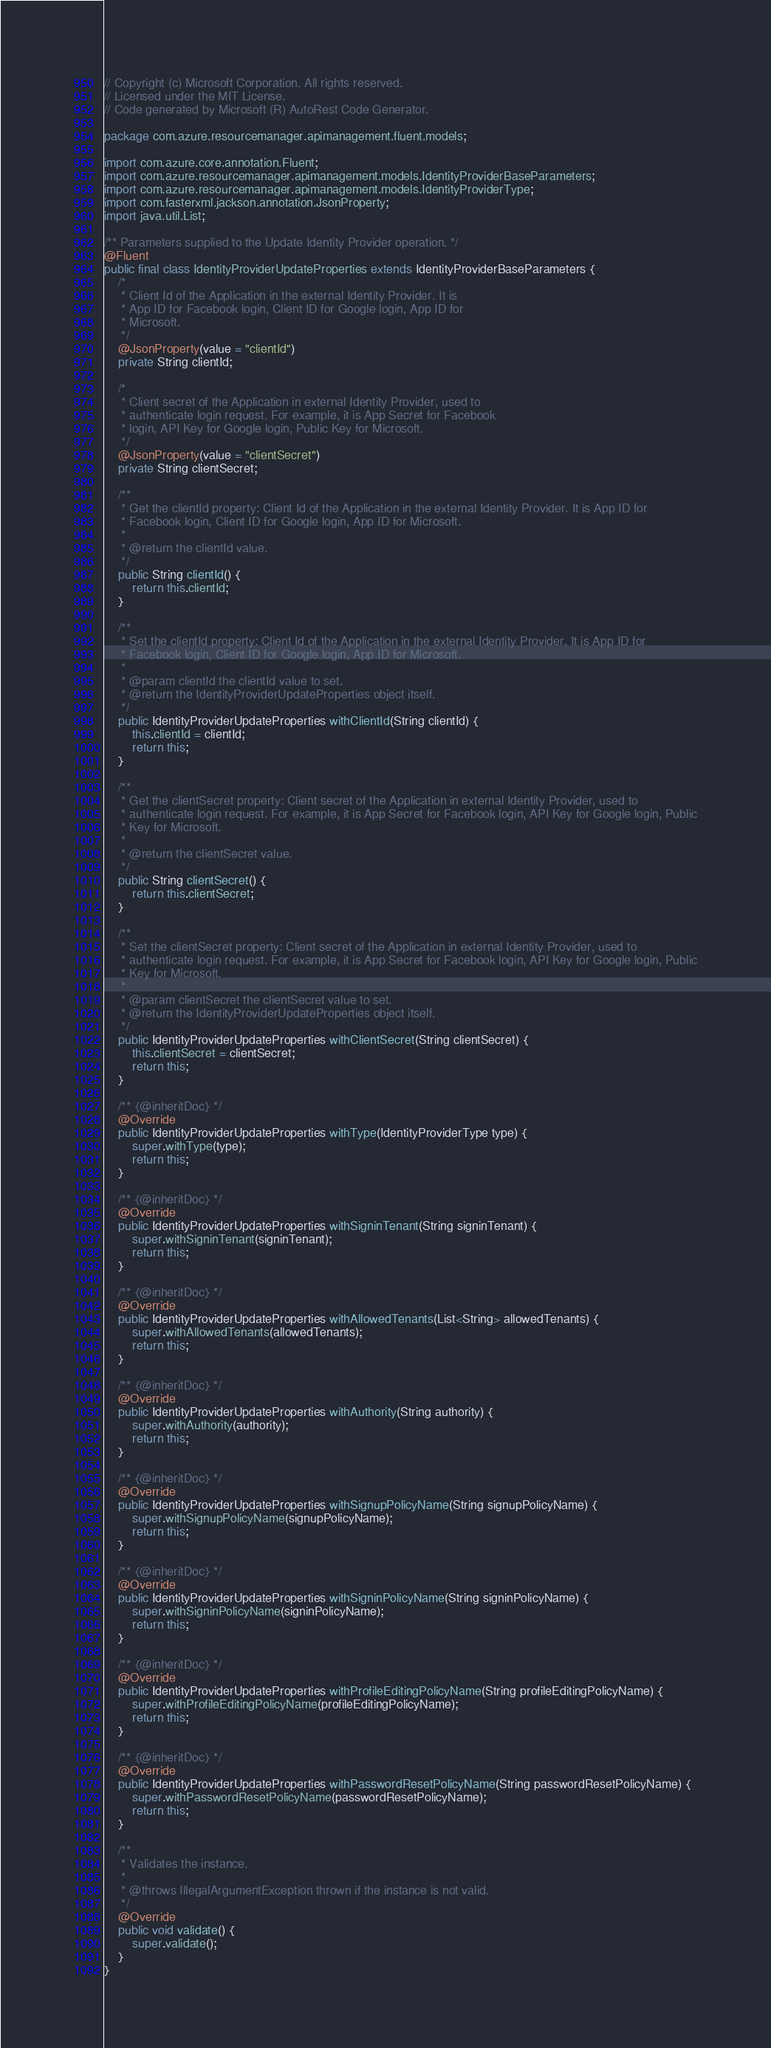Convert code to text. <code><loc_0><loc_0><loc_500><loc_500><_Java_>// Copyright (c) Microsoft Corporation. All rights reserved.
// Licensed under the MIT License.
// Code generated by Microsoft (R) AutoRest Code Generator.

package com.azure.resourcemanager.apimanagement.fluent.models;

import com.azure.core.annotation.Fluent;
import com.azure.resourcemanager.apimanagement.models.IdentityProviderBaseParameters;
import com.azure.resourcemanager.apimanagement.models.IdentityProviderType;
import com.fasterxml.jackson.annotation.JsonProperty;
import java.util.List;

/** Parameters supplied to the Update Identity Provider operation. */
@Fluent
public final class IdentityProviderUpdateProperties extends IdentityProviderBaseParameters {
    /*
     * Client Id of the Application in the external Identity Provider. It is
     * App ID for Facebook login, Client ID for Google login, App ID for
     * Microsoft.
     */
    @JsonProperty(value = "clientId")
    private String clientId;

    /*
     * Client secret of the Application in external Identity Provider, used to
     * authenticate login request. For example, it is App Secret for Facebook
     * login, API Key for Google login, Public Key for Microsoft.
     */
    @JsonProperty(value = "clientSecret")
    private String clientSecret;

    /**
     * Get the clientId property: Client Id of the Application in the external Identity Provider. It is App ID for
     * Facebook login, Client ID for Google login, App ID for Microsoft.
     *
     * @return the clientId value.
     */
    public String clientId() {
        return this.clientId;
    }

    /**
     * Set the clientId property: Client Id of the Application in the external Identity Provider. It is App ID for
     * Facebook login, Client ID for Google login, App ID for Microsoft.
     *
     * @param clientId the clientId value to set.
     * @return the IdentityProviderUpdateProperties object itself.
     */
    public IdentityProviderUpdateProperties withClientId(String clientId) {
        this.clientId = clientId;
        return this;
    }

    /**
     * Get the clientSecret property: Client secret of the Application in external Identity Provider, used to
     * authenticate login request. For example, it is App Secret for Facebook login, API Key for Google login, Public
     * Key for Microsoft.
     *
     * @return the clientSecret value.
     */
    public String clientSecret() {
        return this.clientSecret;
    }

    /**
     * Set the clientSecret property: Client secret of the Application in external Identity Provider, used to
     * authenticate login request. For example, it is App Secret for Facebook login, API Key for Google login, Public
     * Key for Microsoft.
     *
     * @param clientSecret the clientSecret value to set.
     * @return the IdentityProviderUpdateProperties object itself.
     */
    public IdentityProviderUpdateProperties withClientSecret(String clientSecret) {
        this.clientSecret = clientSecret;
        return this;
    }

    /** {@inheritDoc} */
    @Override
    public IdentityProviderUpdateProperties withType(IdentityProviderType type) {
        super.withType(type);
        return this;
    }

    /** {@inheritDoc} */
    @Override
    public IdentityProviderUpdateProperties withSigninTenant(String signinTenant) {
        super.withSigninTenant(signinTenant);
        return this;
    }

    /** {@inheritDoc} */
    @Override
    public IdentityProviderUpdateProperties withAllowedTenants(List<String> allowedTenants) {
        super.withAllowedTenants(allowedTenants);
        return this;
    }

    /** {@inheritDoc} */
    @Override
    public IdentityProviderUpdateProperties withAuthority(String authority) {
        super.withAuthority(authority);
        return this;
    }

    /** {@inheritDoc} */
    @Override
    public IdentityProviderUpdateProperties withSignupPolicyName(String signupPolicyName) {
        super.withSignupPolicyName(signupPolicyName);
        return this;
    }

    /** {@inheritDoc} */
    @Override
    public IdentityProviderUpdateProperties withSigninPolicyName(String signinPolicyName) {
        super.withSigninPolicyName(signinPolicyName);
        return this;
    }

    /** {@inheritDoc} */
    @Override
    public IdentityProviderUpdateProperties withProfileEditingPolicyName(String profileEditingPolicyName) {
        super.withProfileEditingPolicyName(profileEditingPolicyName);
        return this;
    }

    /** {@inheritDoc} */
    @Override
    public IdentityProviderUpdateProperties withPasswordResetPolicyName(String passwordResetPolicyName) {
        super.withPasswordResetPolicyName(passwordResetPolicyName);
        return this;
    }

    /**
     * Validates the instance.
     *
     * @throws IllegalArgumentException thrown if the instance is not valid.
     */
    @Override
    public void validate() {
        super.validate();
    }
}
</code> 